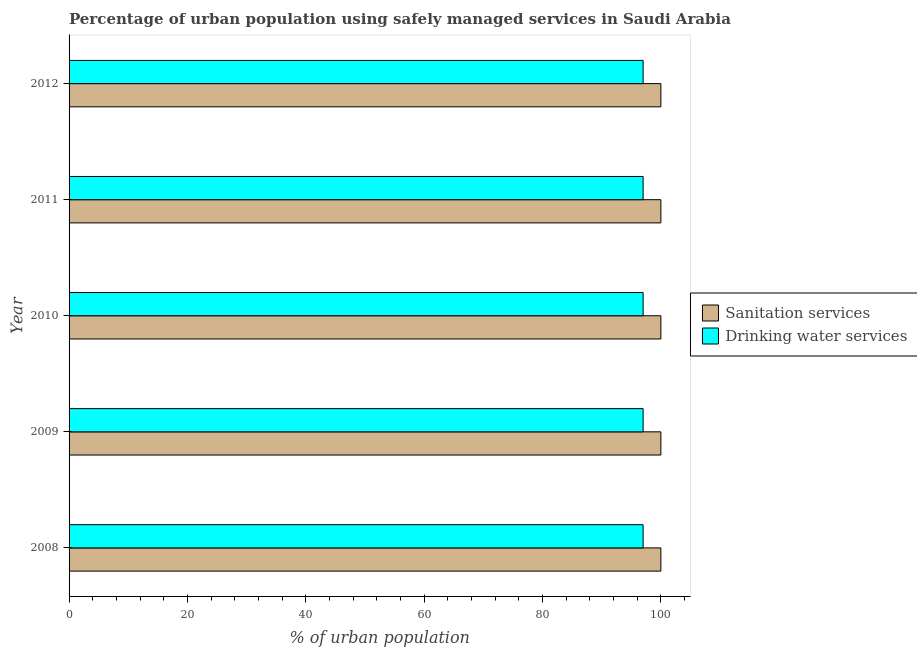How many different coloured bars are there?
Give a very brief answer. 2. Are the number of bars per tick equal to the number of legend labels?
Offer a terse response. Yes. How many bars are there on the 5th tick from the bottom?
Ensure brevity in your answer.  2. What is the label of the 1st group of bars from the top?
Your response must be concise. 2012. In how many cases, is the number of bars for a given year not equal to the number of legend labels?
Provide a short and direct response. 0. What is the percentage of urban population who used drinking water services in 2008?
Offer a very short reply. 97. Across all years, what is the maximum percentage of urban population who used drinking water services?
Make the answer very short. 97. In which year was the percentage of urban population who used sanitation services maximum?
Your answer should be very brief. 2008. In which year was the percentage of urban population who used drinking water services minimum?
Your response must be concise. 2008. What is the total percentage of urban population who used drinking water services in the graph?
Provide a succinct answer. 485. What is the average percentage of urban population who used sanitation services per year?
Your answer should be very brief. 100. In the year 2011, what is the difference between the percentage of urban population who used drinking water services and percentage of urban population who used sanitation services?
Keep it short and to the point. -3. What is the ratio of the percentage of urban population who used drinking water services in 2011 to that in 2012?
Offer a terse response. 1. What is the difference between the highest and the second highest percentage of urban population who used drinking water services?
Your answer should be very brief. 0. What is the difference between the highest and the lowest percentage of urban population who used drinking water services?
Ensure brevity in your answer.  0. Is the sum of the percentage of urban population who used drinking water services in 2008 and 2011 greater than the maximum percentage of urban population who used sanitation services across all years?
Offer a terse response. Yes. What does the 2nd bar from the top in 2008 represents?
Offer a terse response. Sanitation services. What does the 1st bar from the bottom in 2010 represents?
Offer a very short reply. Sanitation services. What is the difference between two consecutive major ticks on the X-axis?
Offer a very short reply. 20. Does the graph contain any zero values?
Make the answer very short. No. How many legend labels are there?
Your answer should be very brief. 2. How are the legend labels stacked?
Give a very brief answer. Vertical. What is the title of the graph?
Provide a short and direct response. Percentage of urban population using safely managed services in Saudi Arabia. What is the label or title of the X-axis?
Keep it short and to the point. % of urban population. What is the label or title of the Y-axis?
Give a very brief answer. Year. What is the % of urban population of Sanitation services in 2008?
Offer a very short reply. 100. What is the % of urban population in Drinking water services in 2008?
Offer a terse response. 97. What is the % of urban population in Sanitation services in 2009?
Your answer should be very brief. 100. What is the % of urban population of Drinking water services in 2009?
Offer a very short reply. 97. What is the % of urban population of Sanitation services in 2010?
Your response must be concise. 100. What is the % of urban population in Drinking water services in 2010?
Your answer should be very brief. 97. What is the % of urban population in Sanitation services in 2011?
Your answer should be very brief. 100. What is the % of urban population in Drinking water services in 2011?
Your answer should be very brief. 97. What is the % of urban population in Drinking water services in 2012?
Provide a succinct answer. 97. Across all years, what is the maximum % of urban population in Drinking water services?
Provide a succinct answer. 97. Across all years, what is the minimum % of urban population of Drinking water services?
Make the answer very short. 97. What is the total % of urban population in Drinking water services in the graph?
Make the answer very short. 485. What is the difference between the % of urban population of Sanitation services in 2008 and that in 2009?
Make the answer very short. 0. What is the difference between the % of urban population of Drinking water services in 2008 and that in 2009?
Offer a very short reply. 0. What is the difference between the % of urban population in Sanitation services in 2008 and that in 2010?
Make the answer very short. 0. What is the difference between the % of urban population in Sanitation services in 2008 and that in 2011?
Give a very brief answer. 0. What is the difference between the % of urban population in Drinking water services in 2008 and that in 2011?
Your answer should be compact. 0. What is the difference between the % of urban population of Sanitation services in 2008 and that in 2012?
Ensure brevity in your answer.  0. What is the difference between the % of urban population of Sanitation services in 2009 and that in 2010?
Offer a very short reply. 0. What is the difference between the % of urban population in Sanitation services in 2009 and that in 2012?
Make the answer very short. 0. What is the difference between the % of urban population of Drinking water services in 2009 and that in 2012?
Provide a succinct answer. 0. What is the difference between the % of urban population of Drinking water services in 2010 and that in 2011?
Provide a short and direct response. 0. What is the difference between the % of urban population in Drinking water services in 2010 and that in 2012?
Keep it short and to the point. 0. What is the difference between the % of urban population in Drinking water services in 2011 and that in 2012?
Provide a succinct answer. 0. What is the difference between the % of urban population in Sanitation services in 2008 and the % of urban population in Drinking water services in 2009?
Provide a succinct answer. 3. What is the difference between the % of urban population in Sanitation services in 2008 and the % of urban population in Drinking water services in 2010?
Provide a short and direct response. 3. What is the difference between the % of urban population in Sanitation services in 2009 and the % of urban population in Drinking water services in 2010?
Make the answer very short. 3. What is the difference between the % of urban population in Sanitation services in 2009 and the % of urban population in Drinking water services in 2011?
Provide a succinct answer. 3. What is the difference between the % of urban population in Sanitation services in 2010 and the % of urban population in Drinking water services in 2011?
Provide a short and direct response. 3. What is the difference between the % of urban population of Sanitation services in 2011 and the % of urban population of Drinking water services in 2012?
Provide a short and direct response. 3. What is the average % of urban population of Sanitation services per year?
Give a very brief answer. 100. What is the average % of urban population in Drinking water services per year?
Keep it short and to the point. 97. In the year 2010, what is the difference between the % of urban population in Sanitation services and % of urban population in Drinking water services?
Offer a terse response. 3. In the year 2011, what is the difference between the % of urban population in Sanitation services and % of urban population in Drinking water services?
Provide a short and direct response. 3. In the year 2012, what is the difference between the % of urban population in Sanitation services and % of urban population in Drinking water services?
Give a very brief answer. 3. What is the ratio of the % of urban population of Sanitation services in 2008 to that in 2010?
Your answer should be very brief. 1. What is the ratio of the % of urban population in Drinking water services in 2008 to that in 2010?
Provide a succinct answer. 1. What is the ratio of the % of urban population of Sanitation services in 2008 to that in 2012?
Keep it short and to the point. 1. What is the ratio of the % of urban population of Drinking water services in 2008 to that in 2012?
Your answer should be very brief. 1. What is the ratio of the % of urban population of Sanitation services in 2009 to that in 2010?
Your answer should be compact. 1. What is the ratio of the % of urban population of Drinking water services in 2009 to that in 2010?
Provide a succinct answer. 1. What is the ratio of the % of urban population of Sanitation services in 2009 to that in 2011?
Make the answer very short. 1. What is the ratio of the % of urban population in Sanitation services in 2009 to that in 2012?
Offer a terse response. 1. What is the ratio of the % of urban population of Sanitation services in 2010 to that in 2012?
Offer a very short reply. 1. What is the ratio of the % of urban population in Sanitation services in 2011 to that in 2012?
Keep it short and to the point. 1. 